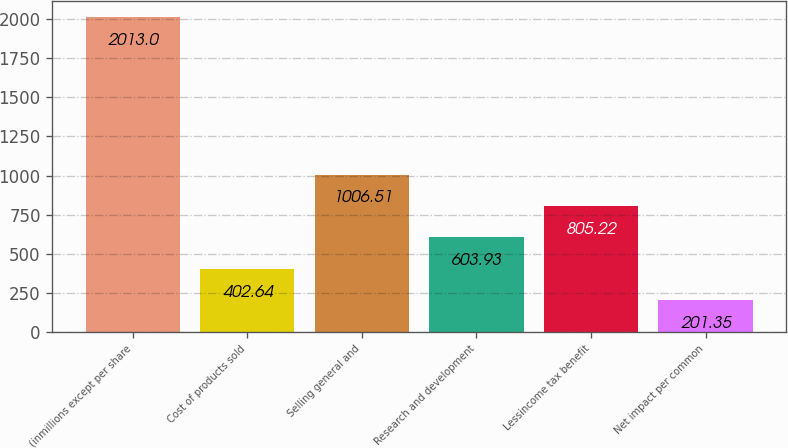<chart> <loc_0><loc_0><loc_500><loc_500><bar_chart><fcel>(inmillions except per share<fcel>Cost of products sold<fcel>Selling general and<fcel>Research and development<fcel>Lessincome tax benefit<fcel>Net impact per common<nl><fcel>2013<fcel>402.64<fcel>1006.51<fcel>603.93<fcel>805.22<fcel>201.35<nl></chart> 